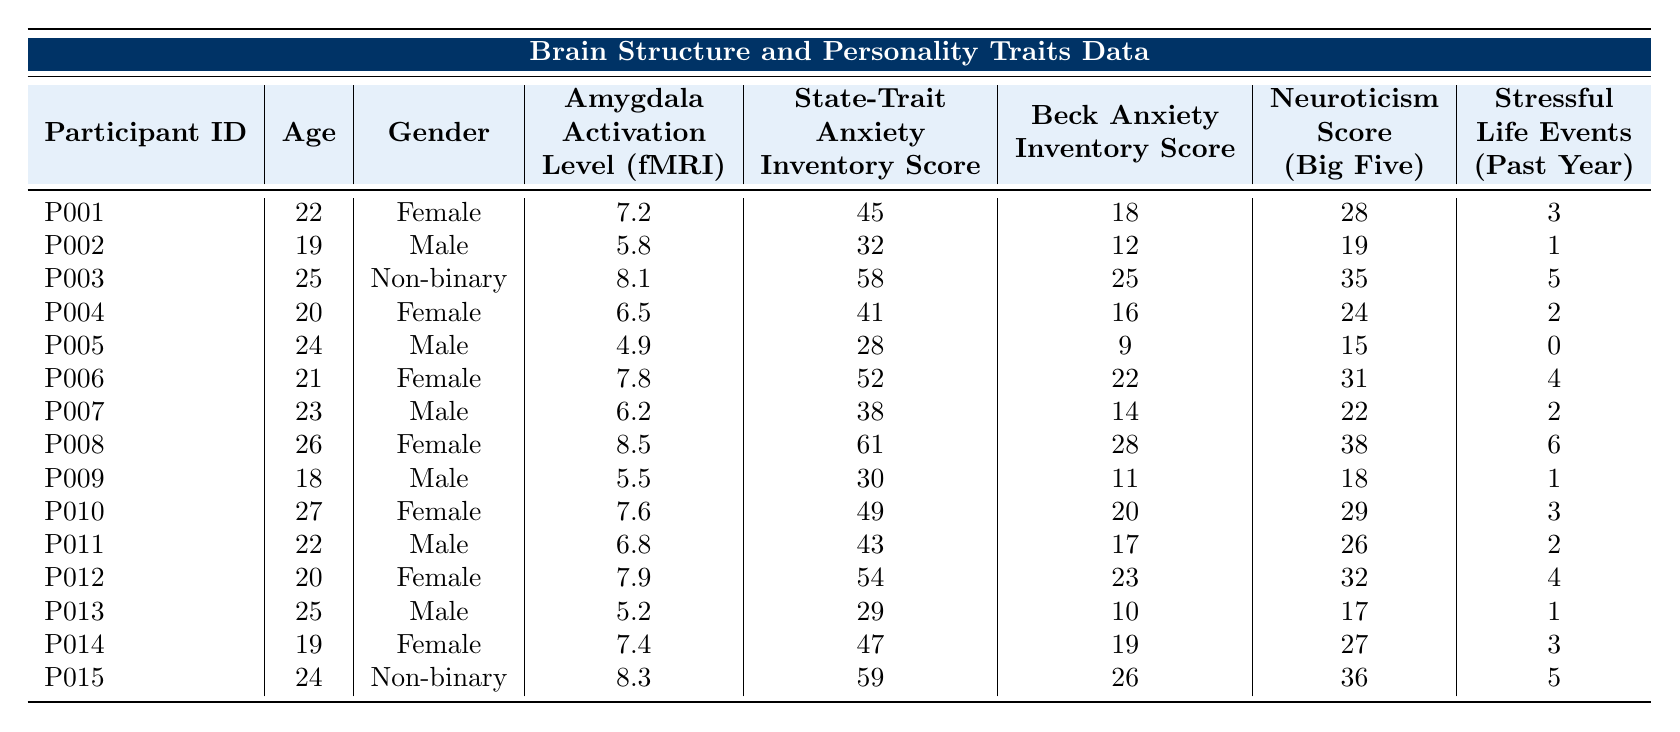What is the amygdala activation level of participant P003? The table shows that the amygdala activation level for participant P003 is listed as 8.1.
Answer: 8.1 How many participants have a Beck Anxiety Inventory score greater than 20? Looking through the Beck Anxiety Inventory scores, participants P003, P006, P008, P010, P012, and P015 have scores greater than 20. This totals to 6 participants.
Answer: 6 What is the average State-Trait Anxiety Inventory score of all participants? The total State-Trait Anxiety Inventory scores are (45 + 32 + 58 + 41 + 28 + 52 + 38 + 61 + 30 + 49 + 43 + 54 + 29 + 47 + 59) =  635. There are 15 participants, so the average is 635 / 15 = 42.33.
Answer: 42.33 Which participant has the highest neuroticism score, and what is that score? By scanning the neuroticism scores, participant P008 has the highest score of 38 among all the participants.
Answer: P008, 38 Is there a participant with an Amygdala activation level below 5? Participant P005 has an amygdala activation level of 4.9, which is below 5, confirming that there is at least one participant with such a level.
Answer: Yes What is the difference in Beck Anxiety Inventory scores between the highest and lowest scores? The highest Beck Anxiety Inventory score is 28 (P008) and the lowest is 9 (P005). The difference is 28 - 9 = 19.
Answer: 19 How many participants report having more than 3 stressful life events in the past year? Participants P003, P008, P006, and P015 reported stressful life events of 5, 6, 4, and 5 respectively. This results in a total of 4 participants reporting more than 3 stressful life events.
Answer: 4 Is there a correlation between higher amygdala activation levels and anxiety inventory scores? To find correlation, we look at participants with higher activation levels (e.g., P003, P008) and their corresponding anxiety scores. P003 has an activation of 8.1 and a score of 58, P008 has an activation of 8.5 and a score of 61. Both suggest higher anxiety with higher activation. Therefore, there seems to be a trend suggesting correlation.
Answer: Yes, a correlation exists What is the age of the participant with the lowest State-Trait Anxiety Inventory score? Participant P005 has the lowest score of 28 on the State-Trait Anxiety Inventory, and their age is listed as 24.
Answer: 24 What is the average age of all male participants? The ages of male participants (P002, P005, P007, P011, P013) are 19, 24, 23, 22, and 25. Their sum is 113. Dividing by the number of male participants (5) gives 113 / 5 = 22.6.
Answer: 22.6 